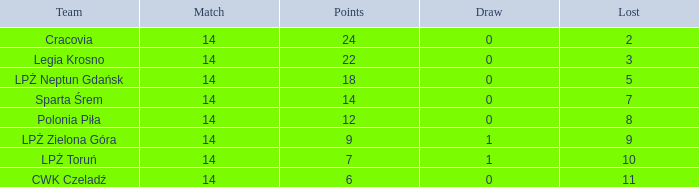What is the total when the game ends in a draw with a negative score? None. 